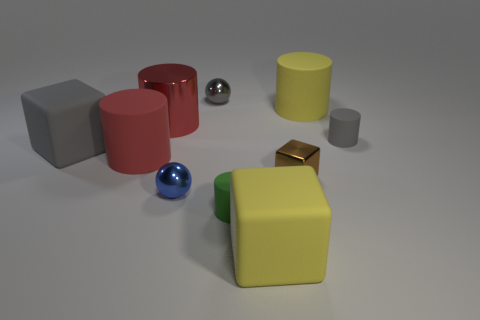Is the number of purple matte spheres greater than the number of small gray balls? No, the number of purple matte spheres is not greater than the number of small gray balls. In fact, there are no purple matte spheres present in the image at all. There is a single small gray ball. 